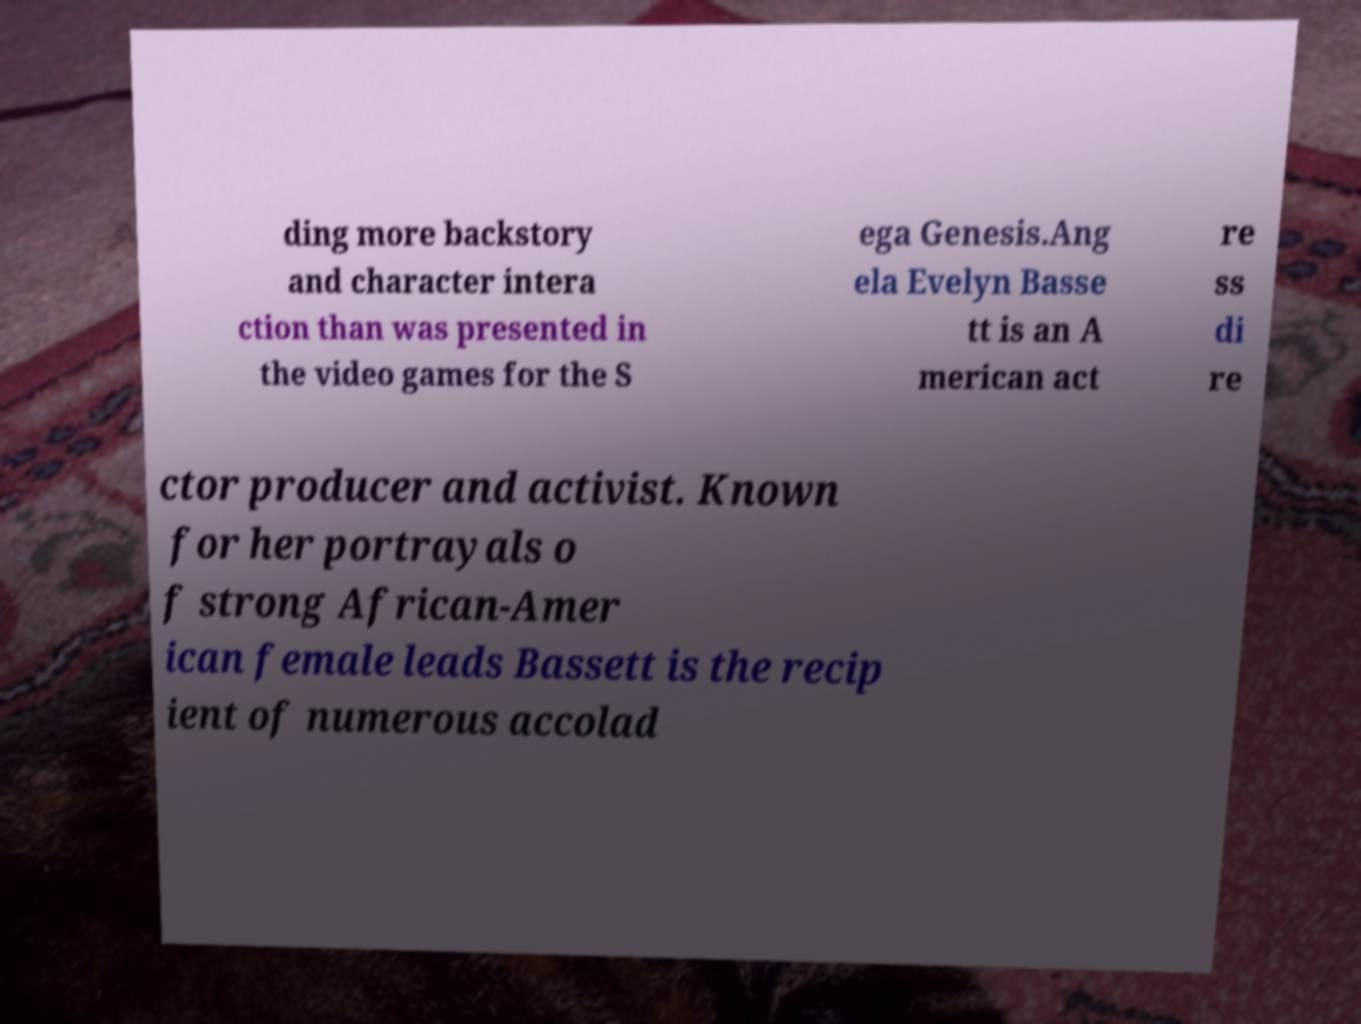Could you assist in decoding the text presented in this image and type it out clearly? ding more backstory and character intera ction than was presented in the video games for the S ega Genesis.Ang ela Evelyn Basse tt is an A merican act re ss di re ctor producer and activist. Known for her portrayals o f strong African-Amer ican female leads Bassett is the recip ient of numerous accolad 